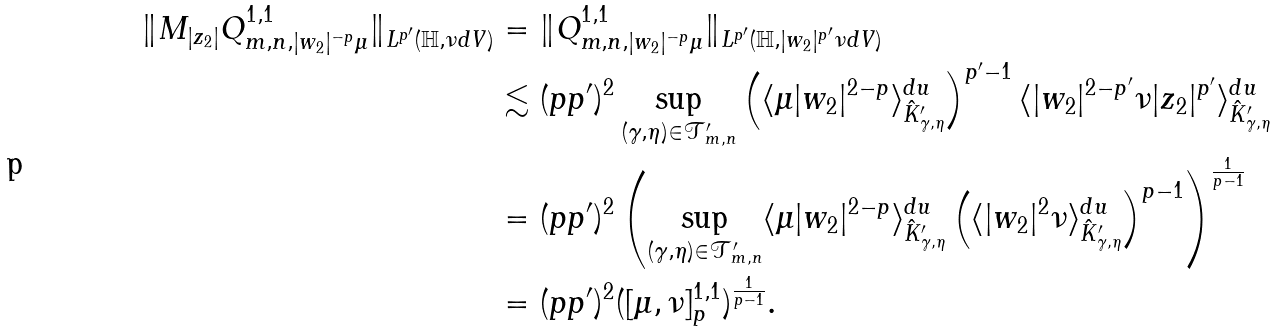Convert formula to latex. <formula><loc_0><loc_0><loc_500><loc_500>\| M _ { | z _ { 2 } | } Q ^ { 1 , 1 } _ { m , n , | w _ { 2 } | ^ { - p } \mu } \| _ { L ^ { p ^ { \prime } } ( \mathbb { H } , \nu d V ) } & = \| Q ^ { 1 , 1 } _ { m , n , | w _ { 2 } | ^ { - p } \mu } \| _ { L ^ { p ^ { \prime } } ( \mathbb { H } , | w _ { 2 } | ^ { p ^ { \prime } } \nu d V ) } \\ & \lesssim ( p p ^ { \prime } ) ^ { 2 } \sup _ { ( \gamma , \eta ) \in \mathcal { T } ^ { \prime } _ { m , n } } \left ( \langle \mu | w _ { 2 } | ^ { 2 - p } \rangle ^ { d u } _ { \hat { K } ^ { \prime } _ { \gamma , \eta } } \right ) ^ { p ^ { \prime } - 1 } \langle | w _ { 2 } | ^ { 2 - p ^ { \prime } } \nu | z _ { 2 } | ^ { p ^ { \prime } } \rangle ^ { d u } _ { \hat { K } ^ { \prime } _ { \gamma , \eta } } \\ & = ( p p ^ { \prime } ) ^ { 2 } \left ( \sup _ { ( \gamma , \eta ) \in \mathcal { T } ^ { \prime } _ { m , n } } \langle \mu | w _ { 2 } | ^ { 2 - p } \rangle ^ { d u } _ { \hat { K } ^ { \prime } _ { \gamma , \eta } } \left ( \langle | w _ { 2 } | ^ { 2 } \nu \rangle ^ { d u } _ { \hat { K } ^ { \prime } _ { \gamma , \eta } } \right ) ^ { p - 1 } \right ) ^ { \frac { 1 } { p - 1 } } \\ & = ( p p ^ { \prime } ) ^ { 2 } ( [ \mu , \nu ] ^ { 1 , 1 } _ { p } ) ^ { \frac { 1 } { p - 1 } } .</formula> 